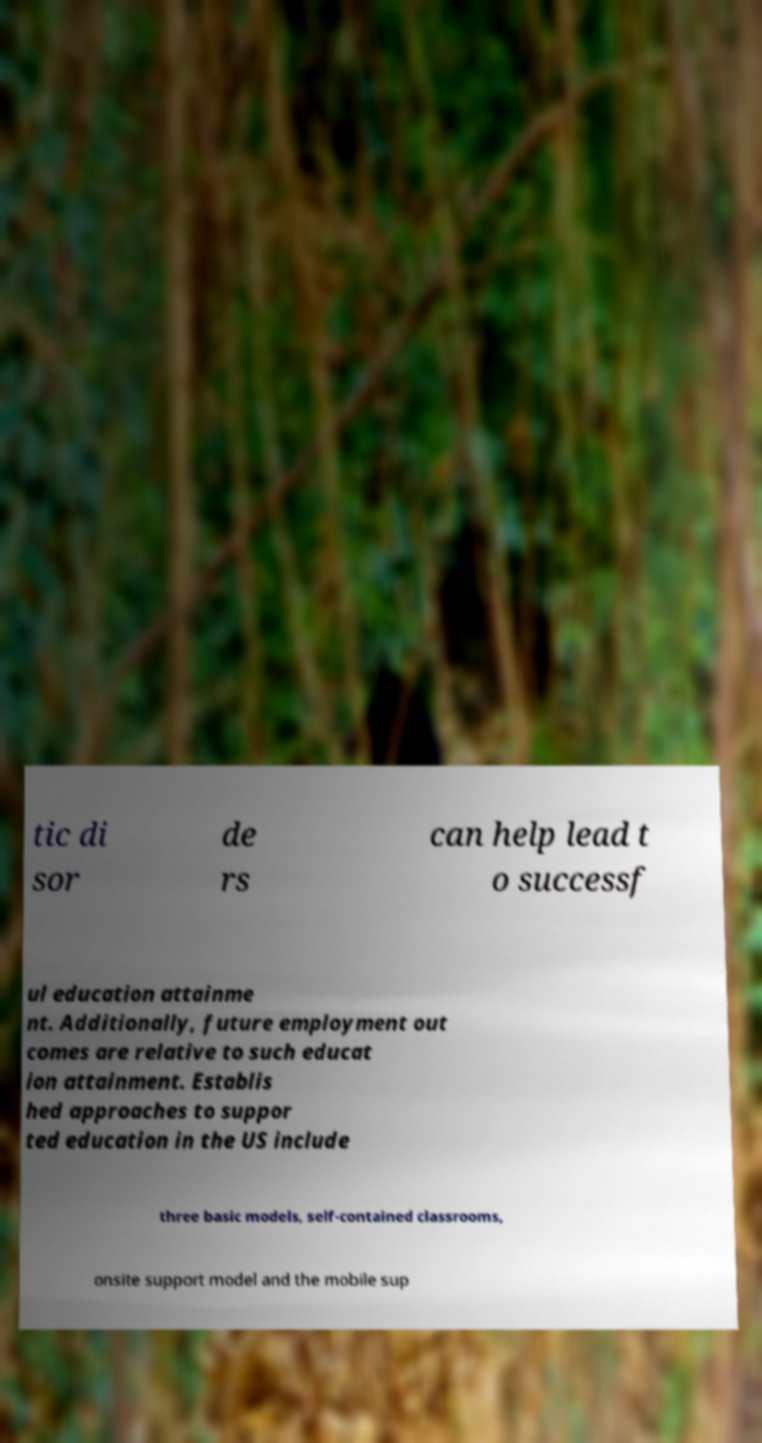There's text embedded in this image that I need extracted. Can you transcribe it verbatim? tic di sor de rs can help lead t o successf ul education attainme nt. Additionally, future employment out comes are relative to such educat ion attainment. Establis hed approaches to suppor ted education in the US include three basic models, self-contained classrooms, onsite support model and the mobile sup 